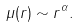<formula> <loc_0><loc_0><loc_500><loc_500>\mu ( r ) \sim r ^ { \alpha } .</formula> 